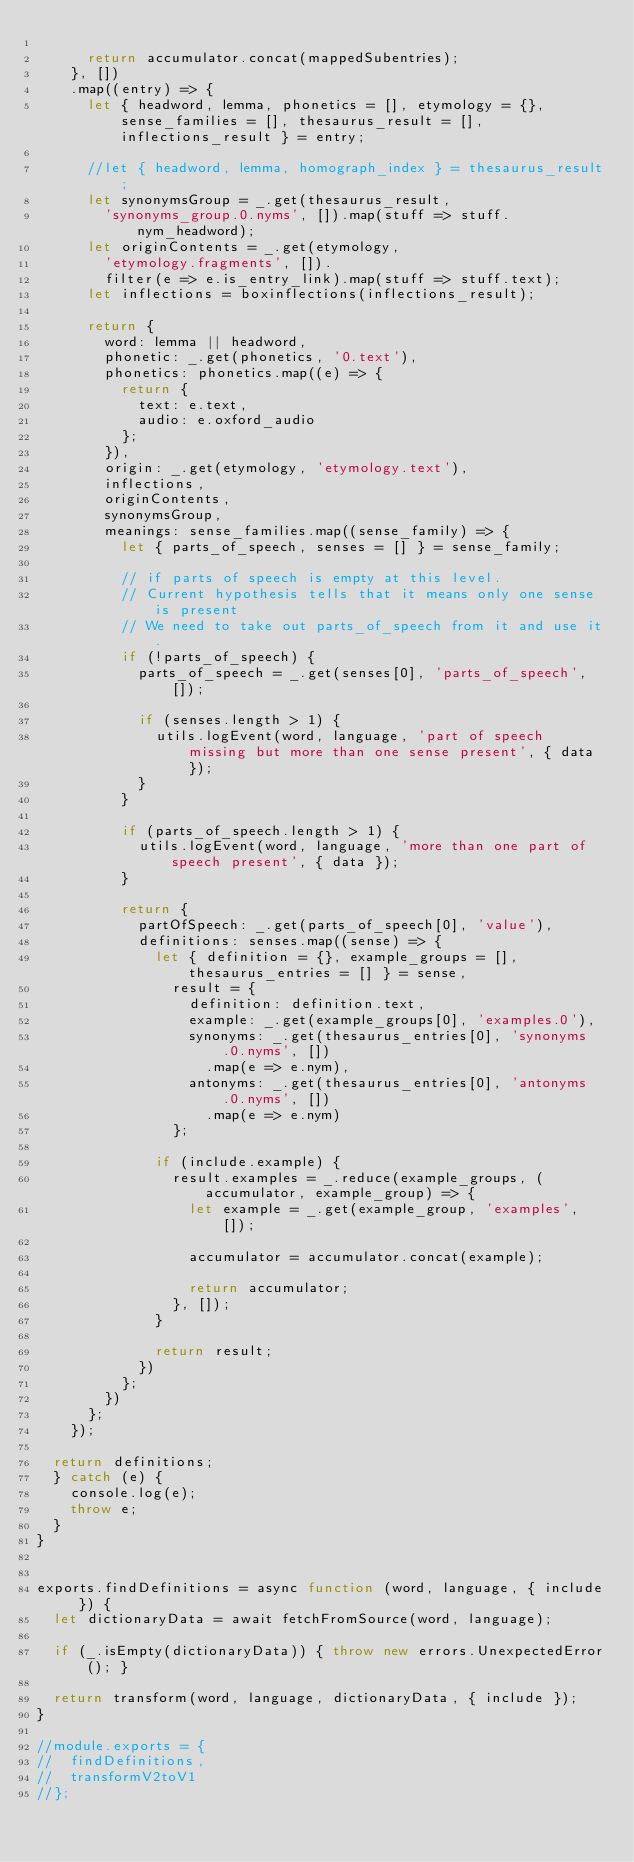Convert code to text. <code><loc_0><loc_0><loc_500><loc_500><_JavaScript_>
			return accumulator.concat(mappedSubentries);
		}, [])
		.map((entry) => {
			let { headword, lemma, phonetics = [], etymology = {}, sense_families = [], thesaurus_result = [], inflections_result } = entry;

			//let { headword, lemma, homograph_index } = thesaurus_result;
			let synonymsGroup = _.get(thesaurus_result,
				'synonyms_group.0.nyms', []).map(stuff => stuff.nym_headword);
			let originContents = _.get(etymology,
				'etymology.fragments', []).
				filter(e => e.is_entry_link).map(stuff => stuff.text);
			let inflections = boxinflections(inflections_result);

			return {
				word: lemma || headword,
				phonetic: _.get(phonetics, '0.text'),
				phonetics: phonetics.map((e) => {
					return {
						text: e.text,
						audio: e.oxford_audio
					};
				}),
				origin: _.get(etymology, 'etymology.text'),
				inflections,
				originContents,
				synonymsGroup,
				meanings: sense_families.map((sense_family) => {
					let { parts_of_speech, senses = [] } = sense_family;

					// if parts of speech is empty at this level.
					// Current hypothesis tells that it means only one sense is present
					// We need to take out parts_of_speech from it and use it.
					if (!parts_of_speech) {
						parts_of_speech = _.get(senses[0], 'parts_of_speech', []);

						if (senses.length > 1) {
							utils.logEvent(word, language, 'part of speech missing but more than one sense present', { data });
						}
					}

					if (parts_of_speech.length > 1) {
						utils.logEvent(word, language, 'more than one part of speech present', { data });
					}

					return {
						partOfSpeech: _.get(parts_of_speech[0], 'value'),
						definitions: senses.map((sense) => {
							let { definition = {}, example_groups = [], thesaurus_entries = [] } = sense,
								result = {
									definition: definition.text,
									example: _.get(example_groups[0], 'examples.0'),
									synonyms: _.get(thesaurus_entries[0], 'synonyms.0.nyms', [])
										.map(e => e.nym),
									antonyms: _.get(thesaurus_entries[0], 'antonyms.0.nyms', [])
										.map(e => e.nym)
								};

							if (include.example) {
								result.examples = _.reduce(example_groups, (accumulator, example_group) => {
									let example = _.get(example_group, 'examples', []);

									accumulator = accumulator.concat(example);

									return accumulator;
								}, []);
							}

							return result;
						})
					};
				})
			};
		});

	return definitions;
	} catch (e) {
		console.log(e);
		throw e;
	}
}


exports.findDefinitions = async function (word, language, { include }) {
	let dictionaryData = await fetchFromSource(word, language);

	if (_.isEmpty(dictionaryData)) { throw new errors.UnexpectedError(); }

	return transform(word, language, dictionaryData, { include });
}

//module.exports = {
//	findDefinitions,
//	transformV2toV1
//};
</code> 